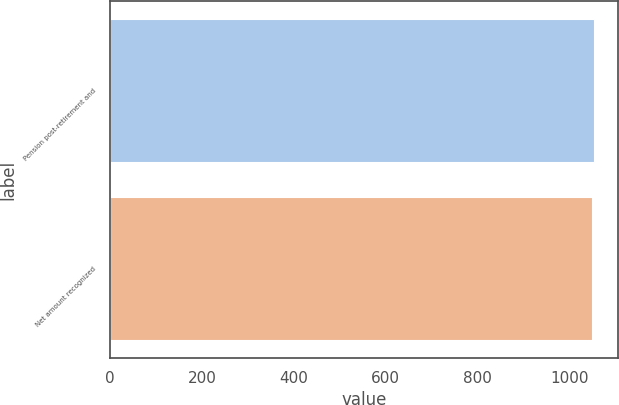Convert chart to OTSL. <chart><loc_0><loc_0><loc_500><loc_500><bar_chart><fcel>Pension post-retirement and<fcel>Net amount recognized<nl><fcel>1053<fcel>1049<nl></chart> 